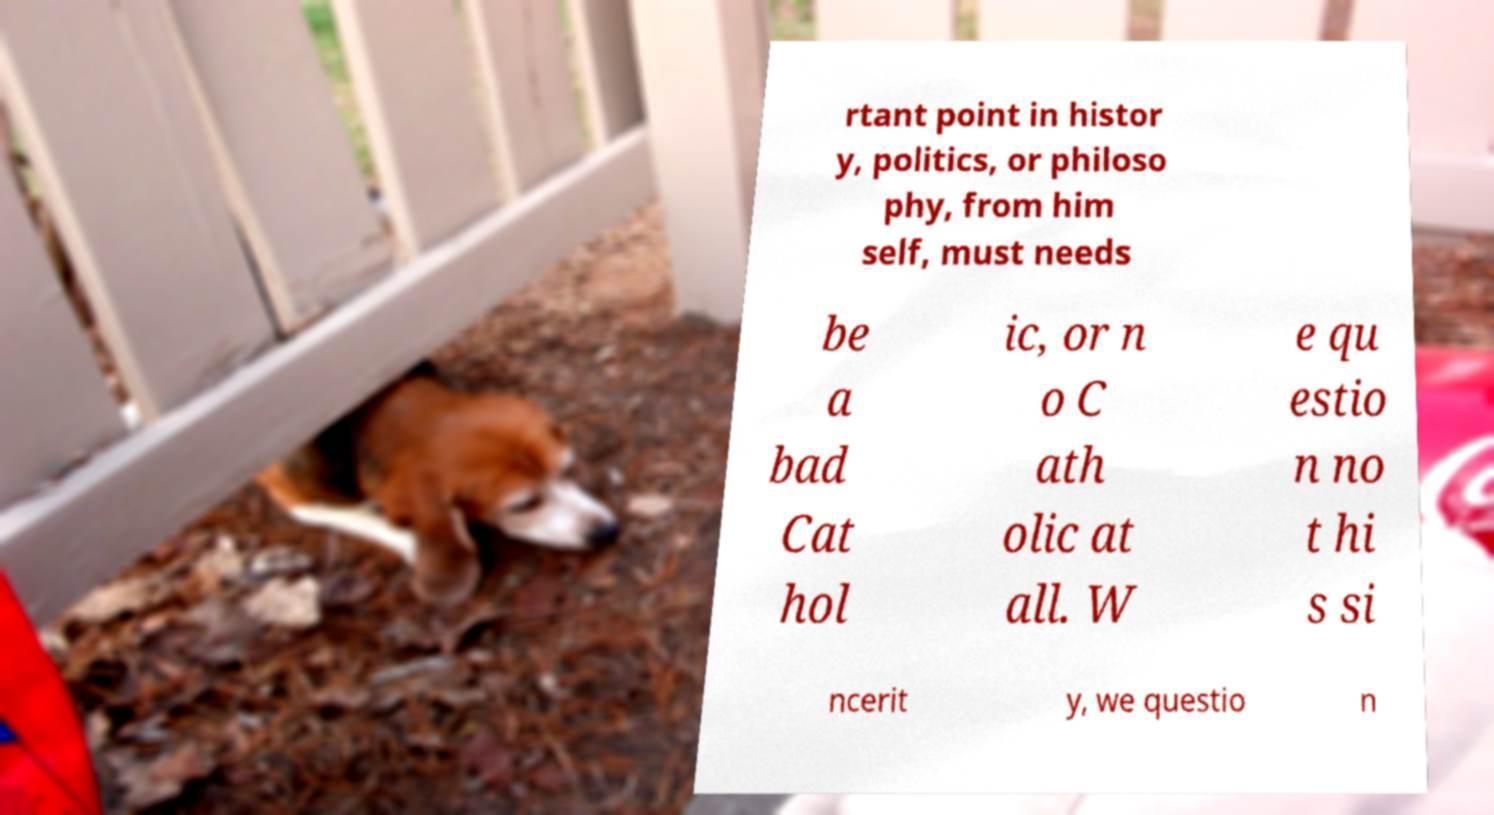Please identify and transcribe the text found in this image. rtant point in histor y, politics, or philoso phy, from him self, must needs be a bad Cat hol ic, or n o C ath olic at all. W e qu estio n no t hi s si ncerit y, we questio n 